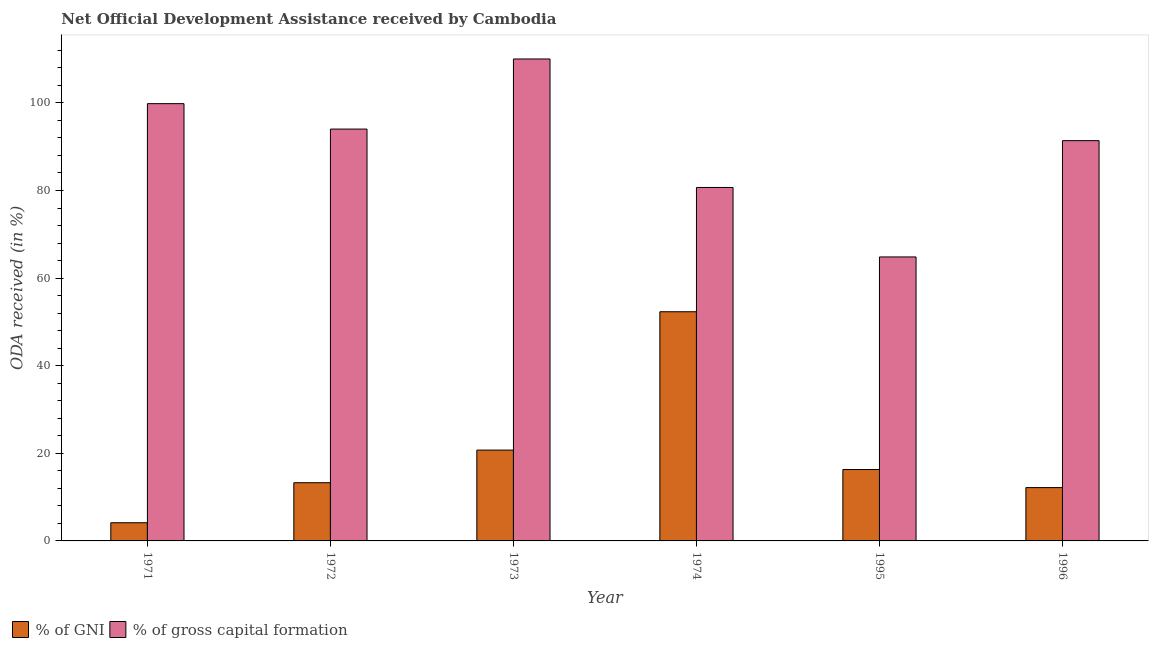How many different coloured bars are there?
Make the answer very short. 2. Are the number of bars on each tick of the X-axis equal?
Keep it short and to the point. Yes. How many bars are there on the 4th tick from the left?
Give a very brief answer. 2. How many bars are there on the 6th tick from the right?
Your response must be concise. 2. What is the label of the 6th group of bars from the left?
Keep it short and to the point. 1996. What is the oda received as percentage of gni in 1972?
Offer a terse response. 13.29. Across all years, what is the maximum oda received as percentage of gni?
Keep it short and to the point. 52.32. Across all years, what is the minimum oda received as percentage of gni?
Offer a very short reply. 4.15. In which year was the oda received as percentage of gni maximum?
Your response must be concise. 1974. What is the total oda received as percentage of gni in the graph?
Your response must be concise. 118.97. What is the difference between the oda received as percentage of gni in 1974 and that in 1995?
Your response must be concise. 36.02. What is the difference between the oda received as percentage of gross capital formation in 1973 and the oda received as percentage of gni in 1996?
Provide a succinct answer. 18.65. What is the average oda received as percentage of gross capital formation per year?
Provide a short and direct response. 90.13. In how many years, is the oda received as percentage of gross capital formation greater than 84 %?
Keep it short and to the point. 4. What is the ratio of the oda received as percentage of gross capital formation in 1971 to that in 1972?
Provide a succinct answer. 1.06. Is the oda received as percentage of gni in 1972 less than that in 1995?
Give a very brief answer. Yes. What is the difference between the highest and the second highest oda received as percentage of gni?
Keep it short and to the point. 31.58. What is the difference between the highest and the lowest oda received as percentage of gross capital formation?
Keep it short and to the point. 45.2. In how many years, is the oda received as percentage of gross capital formation greater than the average oda received as percentage of gross capital formation taken over all years?
Your answer should be compact. 4. What does the 1st bar from the left in 1972 represents?
Your response must be concise. % of GNI. What does the 1st bar from the right in 1995 represents?
Offer a terse response. % of gross capital formation. How many bars are there?
Ensure brevity in your answer.  12. Are all the bars in the graph horizontal?
Provide a short and direct response. No. How many years are there in the graph?
Your answer should be very brief. 6. What is the difference between two consecutive major ticks on the Y-axis?
Offer a very short reply. 20. Does the graph contain any zero values?
Offer a terse response. No. Does the graph contain grids?
Make the answer very short. No. Where does the legend appear in the graph?
Your answer should be compact. Bottom left. How are the legend labels stacked?
Give a very brief answer. Horizontal. What is the title of the graph?
Make the answer very short. Net Official Development Assistance received by Cambodia. Does "Investment in Transport" appear as one of the legend labels in the graph?
Offer a very short reply. No. What is the label or title of the Y-axis?
Give a very brief answer. ODA received (in %). What is the ODA received (in %) of % of GNI in 1971?
Your answer should be compact. 4.15. What is the ODA received (in %) in % of gross capital formation in 1971?
Give a very brief answer. 99.83. What is the ODA received (in %) in % of GNI in 1972?
Ensure brevity in your answer.  13.29. What is the ODA received (in %) in % of gross capital formation in 1972?
Offer a terse response. 94.03. What is the ODA received (in %) of % of GNI in 1973?
Your answer should be very brief. 20.74. What is the ODA received (in %) in % of gross capital formation in 1973?
Ensure brevity in your answer.  110.03. What is the ODA received (in %) of % of GNI in 1974?
Your answer should be very brief. 52.32. What is the ODA received (in %) of % of gross capital formation in 1974?
Ensure brevity in your answer.  80.69. What is the ODA received (in %) in % of GNI in 1995?
Provide a succinct answer. 16.3. What is the ODA received (in %) of % of gross capital formation in 1995?
Offer a terse response. 64.83. What is the ODA received (in %) in % of GNI in 1996?
Your answer should be very brief. 12.17. What is the ODA received (in %) of % of gross capital formation in 1996?
Offer a very short reply. 91.38. Across all years, what is the maximum ODA received (in %) in % of GNI?
Offer a very short reply. 52.32. Across all years, what is the maximum ODA received (in %) of % of gross capital formation?
Provide a short and direct response. 110.03. Across all years, what is the minimum ODA received (in %) in % of GNI?
Give a very brief answer. 4.15. Across all years, what is the minimum ODA received (in %) in % of gross capital formation?
Give a very brief answer. 64.83. What is the total ODA received (in %) in % of GNI in the graph?
Your response must be concise. 118.97. What is the total ODA received (in %) in % of gross capital formation in the graph?
Offer a terse response. 540.8. What is the difference between the ODA received (in %) of % of GNI in 1971 and that in 1972?
Make the answer very short. -9.14. What is the difference between the ODA received (in %) in % of gross capital formation in 1971 and that in 1972?
Offer a very short reply. 5.8. What is the difference between the ODA received (in %) in % of GNI in 1971 and that in 1973?
Give a very brief answer. -16.59. What is the difference between the ODA received (in %) of % of gross capital formation in 1971 and that in 1973?
Provide a succinct answer. -10.2. What is the difference between the ODA received (in %) in % of GNI in 1971 and that in 1974?
Your answer should be very brief. -48.17. What is the difference between the ODA received (in %) in % of gross capital formation in 1971 and that in 1974?
Give a very brief answer. 19.14. What is the difference between the ODA received (in %) of % of GNI in 1971 and that in 1995?
Provide a succinct answer. -12.15. What is the difference between the ODA received (in %) of % of gross capital formation in 1971 and that in 1995?
Ensure brevity in your answer.  35. What is the difference between the ODA received (in %) of % of GNI in 1971 and that in 1996?
Make the answer very short. -8.02. What is the difference between the ODA received (in %) in % of gross capital formation in 1971 and that in 1996?
Your answer should be compact. 8.45. What is the difference between the ODA received (in %) of % of GNI in 1972 and that in 1973?
Make the answer very short. -7.45. What is the difference between the ODA received (in %) in % of gross capital formation in 1972 and that in 1973?
Keep it short and to the point. -16. What is the difference between the ODA received (in %) of % of GNI in 1972 and that in 1974?
Make the answer very short. -39.03. What is the difference between the ODA received (in %) in % of gross capital formation in 1972 and that in 1974?
Ensure brevity in your answer.  13.33. What is the difference between the ODA received (in %) of % of GNI in 1972 and that in 1995?
Give a very brief answer. -3.01. What is the difference between the ODA received (in %) in % of gross capital formation in 1972 and that in 1995?
Keep it short and to the point. 29.19. What is the difference between the ODA received (in %) in % of GNI in 1972 and that in 1996?
Your answer should be compact. 1.12. What is the difference between the ODA received (in %) in % of gross capital formation in 1972 and that in 1996?
Your answer should be compact. 2.64. What is the difference between the ODA received (in %) in % of GNI in 1973 and that in 1974?
Your response must be concise. -31.58. What is the difference between the ODA received (in %) of % of gross capital formation in 1973 and that in 1974?
Give a very brief answer. 29.34. What is the difference between the ODA received (in %) in % of GNI in 1973 and that in 1995?
Offer a terse response. 4.44. What is the difference between the ODA received (in %) in % of gross capital formation in 1973 and that in 1995?
Your answer should be compact. 45.2. What is the difference between the ODA received (in %) in % of GNI in 1973 and that in 1996?
Ensure brevity in your answer.  8.56. What is the difference between the ODA received (in %) of % of gross capital formation in 1973 and that in 1996?
Make the answer very short. 18.65. What is the difference between the ODA received (in %) of % of GNI in 1974 and that in 1995?
Provide a short and direct response. 36.02. What is the difference between the ODA received (in %) of % of gross capital formation in 1974 and that in 1995?
Offer a terse response. 15.86. What is the difference between the ODA received (in %) in % of GNI in 1974 and that in 1996?
Your answer should be compact. 40.15. What is the difference between the ODA received (in %) of % of gross capital formation in 1974 and that in 1996?
Your answer should be very brief. -10.69. What is the difference between the ODA received (in %) in % of GNI in 1995 and that in 1996?
Offer a terse response. 4.13. What is the difference between the ODA received (in %) of % of gross capital formation in 1995 and that in 1996?
Provide a short and direct response. -26.55. What is the difference between the ODA received (in %) of % of GNI in 1971 and the ODA received (in %) of % of gross capital formation in 1972?
Your answer should be very brief. -89.88. What is the difference between the ODA received (in %) of % of GNI in 1971 and the ODA received (in %) of % of gross capital formation in 1973?
Provide a succinct answer. -105.88. What is the difference between the ODA received (in %) of % of GNI in 1971 and the ODA received (in %) of % of gross capital formation in 1974?
Your answer should be very brief. -76.54. What is the difference between the ODA received (in %) of % of GNI in 1971 and the ODA received (in %) of % of gross capital formation in 1995?
Provide a short and direct response. -60.68. What is the difference between the ODA received (in %) of % of GNI in 1971 and the ODA received (in %) of % of gross capital formation in 1996?
Provide a short and direct response. -87.23. What is the difference between the ODA received (in %) of % of GNI in 1972 and the ODA received (in %) of % of gross capital formation in 1973?
Provide a succinct answer. -96.74. What is the difference between the ODA received (in %) of % of GNI in 1972 and the ODA received (in %) of % of gross capital formation in 1974?
Offer a very short reply. -67.4. What is the difference between the ODA received (in %) of % of GNI in 1972 and the ODA received (in %) of % of gross capital formation in 1995?
Your response must be concise. -51.54. What is the difference between the ODA received (in %) in % of GNI in 1972 and the ODA received (in %) in % of gross capital formation in 1996?
Keep it short and to the point. -78.09. What is the difference between the ODA received (in %) in % of GNI in 1973 and the ODA received (in %) in % of gross capital formation in 1974?
Provide a succinct answer. -59.96. What is the difference between the ODA received (in %) of % of GNI in 1973 and the ODA received (in %) of % of gross capital formation in 1995?
Your answer should be very brief. -44.09. What is the difference between the ODA received (in %) of % of GNI in 1973 and the ODA received (in %) of % of gross capital formation in 1996?
Ensure brevity in your answer.  -70.64. What is the difference between the ODA received (in %) in % of GNI in 1974 and the ODA received (in %) in % of gross capital formation in 1995?
Offer a very short reply. -12.51. What is the difference between the ODA received (in %) of % of GNI in 1974 and the ODA received (in %) of % of gross capital formation in 1996?
Ensure brevity in your answer.  -39.06. What is the difference between the ODA received (in %) of % of GNI in 1995 and the ODA received (in %) of % of gross capital formation in 1996?
Your answer should be compact. -75.08. What is the average ODA received (in %) of % of GNI per year?
Keep it short and to the point. 19.83. What is the average ODA received (in %) in % of gross capital formation per year?
Your answer should be compact. 90.13. In the year 1971, what is the difference between the ODA received (in %) in % of GNI and ODA received (in %) in % of gross capital formation?
Provide a short and direct response. -95.68. In the year 1972, what is the difference between the ODA received (in %) in % of GNI and ODA received (in %) in % of gross capital formation?
Your response must be concise. -80.74. In the year 1973, what is the difference between the ODA received (in %) of % of GNI and ODA received (in %) of % of gross capital formation?
Make the answer very short. -89.29. In the year 1974, what is the difference between the ODA received (in %) in % of GNI and ODA received (in %) in % of gross capital formation?
Offer a terse response. -28.37. In the year 1995, what is the difference between the ODA received (in %) of % of GNI and ODA received (in %) of % of gross capital formation?
Your answer should be compact. -48.53. In the year 1996, what is the difference between the ODA received (in %) of % of GNI and ODA received (in %) of % of gross capital formation?
Offer a terse response. -79.21. What is the ratio of the ODA received (in %) in % of GNI in 1971 to that in 1972?
Ensure brevity in your answer.  0.31. What is the ratio of the ODA received (in %) in % of gross capital formation in 1971 to that in 1972?
Your answer should be very brief. 1.06. What is the ratio of the ODA received (in %) in % of GNI in 1971 to that in 1973?
Your response must be concise. 0.2. What is the ratio of the ODA received (in %) of % of gross capital formation in 1971 to that in 1973?
Provide a succinct answer. 0.91. What is the ratio of the ODA received (in %) of % of GNI in 1971 to that in 1974?
Provide a succinct answer. 0.08. What is the ratio of the ODA received (in %) in % of gross capital formation in 1971 to that in 1974?
Your answer should be compact. 1.24. What is the ratio of the ODA received (in %) in % of GNI in 1971 to that in 1995?
Your response must be concise. 0.25. What is the ratio of the ODA received (in %) in % of gross capital formation in 1971 to that in 1995?
Keep it short and to the point. 1.54. What is the ratio of the ODA received (in %) in % of GNI in 1971 to that in 1996?
Your response must be concise. 0.34. What is the ratio of the ODA received (in %) of % of gross capital formation in 1971 to that in 1996?
Provide a short and direct response. 1.09. What is the ratio of the ODA received (in %) of % of GNI in 1972 to that in 1973?
Your response must be concise. 0.64. What is the ratio of the ODA received (in %) of % of gross capital formation in 1972 to that in 1973?
Offer a very short reply. 0.85. What is the ratio of the ODA received (in %) of % of GNI in 1972 to that in 1974?
Provide a succinct answer. 0.25. What is the ratio of the ODA received (in %) of % of gross capital formation in 1972 to that in 1974?
Keep it short and to the point. 1.17. What is the ratio of the ODA received (in %) of % of GNI in 1972 to that in 1995?
Your answer should be very brief. 0.82. What is the ratio of the ODA received (in %) of % of gross capital formation in 1972 to that in 1995?
Make the answer very short. 1.45. What is the ratio of the ODA received (in %) in % of GNI in 1972 to that in 1996?
Ensure brevity in your answer.  1.09. What is the ratio of the ODA received (in %) in % of gross capital formation in 1972 to that in 1996?
Give a very brief answer. 1.03. What is the ratio of the ODA received (in %) of % of GNI in 1973 to that in 1974?
Give a very brief answer. 0.4. What is the ratio of the ODA received (in %) of % of gross capital formation in 1973 to that in 1974?
Offer a very short reply. 1.36. What is the ratio of the ODA received (in %) in % of GNI in 1973 to that in 1995?
Your answer should be very brief. 1.27. What is the ratio of the ODA received (in %) in % of gross capital formation in 1973 to that in 1995?
Your response must be concise. 1.7. What is the ratio of the ODA received (in %) of % of GNI in 1973 to that in 1996?
Give a very brief answer. 1.7. What is the ratio of the ODA received (in %) of % of gross capital formation in 1973 to that in 1996?
Provide a succinct answer. 1.2. What is the ratio of the ODA received (in %) in % of GNI in 1974 to that in 1995?
Ensure brevity in your answer.  3.21. What is the ratio of the ODA received (in %) in % of gross capital formation in 1974 to that in 1995?
Provide a short and direct response. 1.24. What is the ratio of the ODA received (in %) of % of GNI in 1974 to that in 1996?
Provide a short and direct response. 4.3. What is the ratio of the ODA received (in %) in % of gross capital formation in 1974 to that in 1996?
Keep it short and to the point. 0.88. What is the ratio of the ODA received (in %) in % of GNI in 1995 to that in 1996?
Give a very brief answer. 1.34. What is the ratio of the ODA received (in %) in % of gross capital formation in 1995 to that in 1996?
Offer a very short reply. 0.71. What is the difference between the highest and the second highest ODA received (in %) of % of GNI?
Offer a terse response. 31.58. What is the difference between the highest and the second highest ODA received (in %) in % of gross capital formation?
Provide a succinct answer. 10.2. What is the difference between the highest and the lowest ODA received (in %) of % of GNI?
Your answer should be compact. 48.17. What is the difference between the highest and the lowest ODA received (in %) in % of gross capital formation?
Keep it short and to the point. 45.2. 